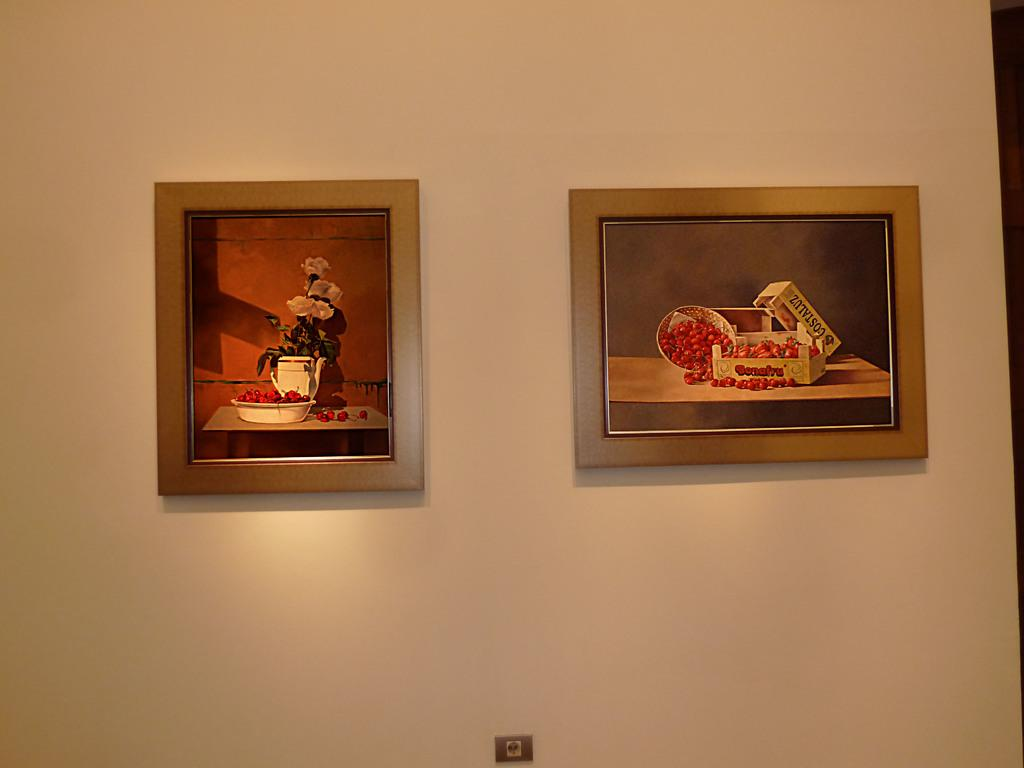What can be seen in the background of the image? There is a wall in the image. What is placed on the wall? There are frames placed on the wall. What type of silk is used to cover the frames on the wall? There is no mention of silk or any fabric covering the frames in the image. 